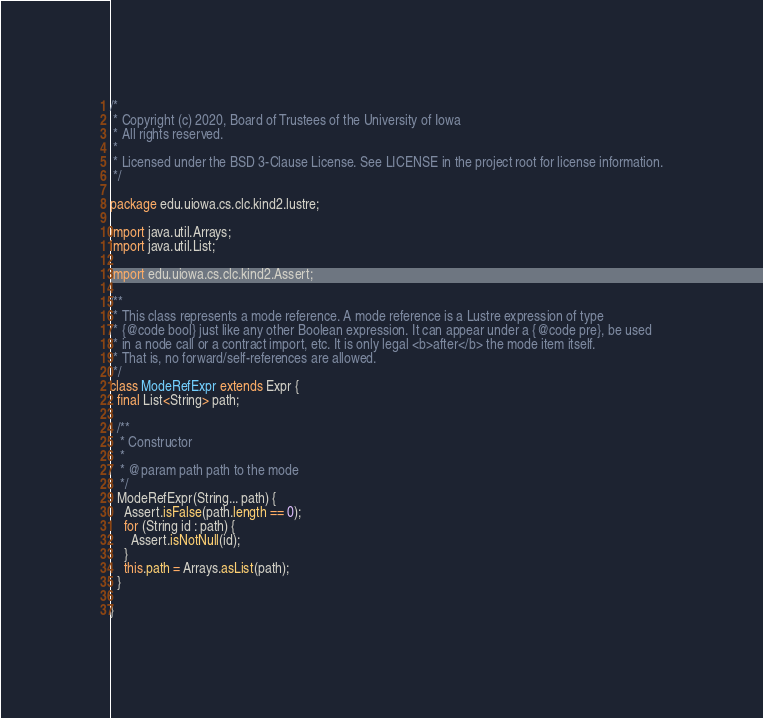<code> <loc_0><loc_0><loc_500><loc_500><_Java_>/*
 * Copyright (c) 2020, Board of Trustees of the University of Iowa
 * All rights reserved.
 *
 * Licensed under the BSD 3-Clause License. See LICENSE in the project root for license information.
 */

package edu.uiowa.cs.clc.kind2.lustre;

import java.util.Arrays;
import java.util.List;

import edu.uiowa.cs.clc.kind2.Assert;

/**
 * This class represents a mode reference. A mode reference is a Lustre expression of type
 * {@code bool} just like any other Boolean expression. It can appear under a {@code pre}, be used
 * in a node call or a contract import, etc. It is only legal <b>after</b> the mode item itself.
 * That is, no forward/self-references are allowed.
 */
class ModeRefExpr extends Expr {
  final List<String> path;

  /**
   * Constructor
   *
   * @param path path to the mode
   */
  ModeRefExpr(String... path) {
    Assert.isFalse(path.length == 0);
    for (String id : path) {
      Assert.isNotNull(id);
    }
    this.path = Arrays.asList(path);
  }

}
</code> 